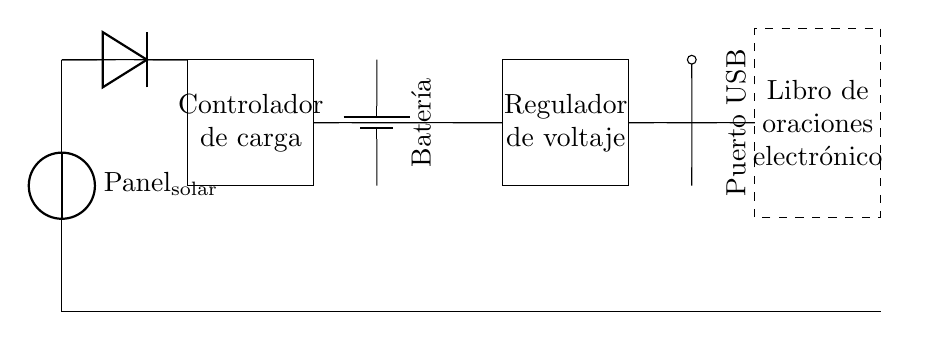What is the main power source for this circuit? The main power source is the solar panel, which converts sunlight into electrical energy to charge the battery.
Answer: Solar panel What component is responsible for preventing reverse current? The diode prevents reverse current from flowing back into the solar panel, ensuring that electricity only flows in one direction.
Answer: Diode How many components are used in total? There are five main components: a solar panel, a diode, a charge controller, a battery, and a voltage regulator, plus the USB port and the portable prayer book.
Answer: Seven What type of device is ultimately powered by this circuit? The circuit is designed to power an electronic prayer book, which is connected to the USB charging port for charging.
Answer: Electronic prayer book What function does the charge controller serve in this circuit? The charge controller manages the battery charging process, ensuring that it does not overcharge or discharge excessively, thus prolonging its life and efficiency.
Answer: Regulates charging Which component provides voltage stability for the USB charging port? The voltage regulator is responsible for providing stable voltage output to the USB charging port, making it safe for the connected device.
Answer: Voltage regulator 